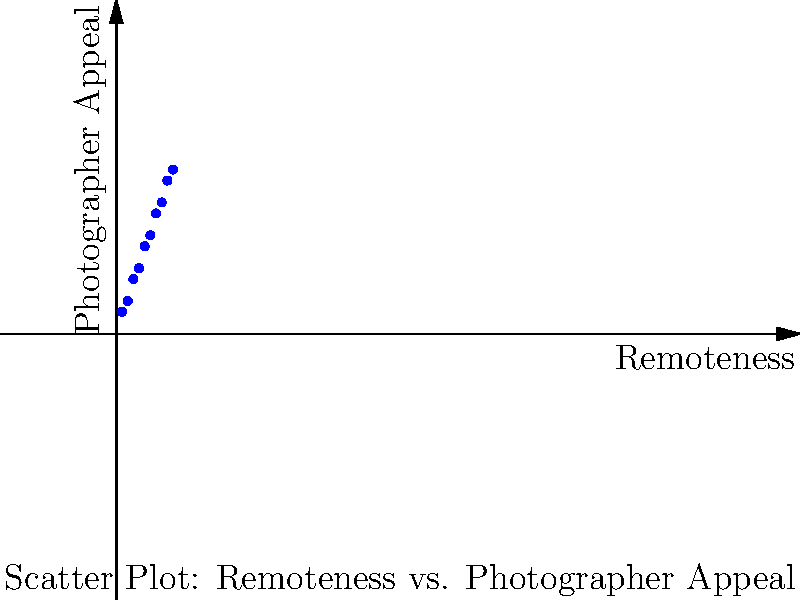Based on the scatter plot showing the relationship between a destination's remoteness and its appeal to photographers, what can you conclude about the trend, and how might this information influence your recommendations for under-the-radar destinations? To answer this question, let's analyze the scatter plot step by step:

1. Observe the overall trend: The points on the graph show a clear upward trend from left to right.

2. Interpret the axes:
   - X-axis represents "Remoteness"
   - Y-axis represents "Photographer Appeal"

3. Understand the relationship: As remoteness increases, photographer appeal tends to increase as well.

4. Quantify the relationship: The trend appears to be roughly linear, with a positive slope.

5. Consider outliers: There don't appear to be any significant outliers that deviate from the general trend.

6. Apply to the travel agency context:
   a. Photographers are likely to be more interested in remote destinations.
   b. Under-the-radar destinations are often more remote, aligning with photographer preferences.
   c. Recommending remote locations could satisfy photographers seeking unique photo opportunities.

7. Potential recommendations:
   a. Focus on promoting lesser-known, remote destinations to photographers.
   b. Highlight the unique photographic opportunities in these remote locations.
   c. Consider creating photography-focused tours to remote areas.

8. Limitations to consider:
   a. Other factors beyond remoteness may influence photographer appeal.
   b. Individual preferences may vary among photographers.

Based on this analysis, the trend suggests a positive correlation between remoteness and photographer appeal, which can guide recommendations for under-the-radar destinations that are likely to interest photographers.
Answer: Positive correlation between remoteness and photographer appeal; recommend remote, under-the-radar destinations. 